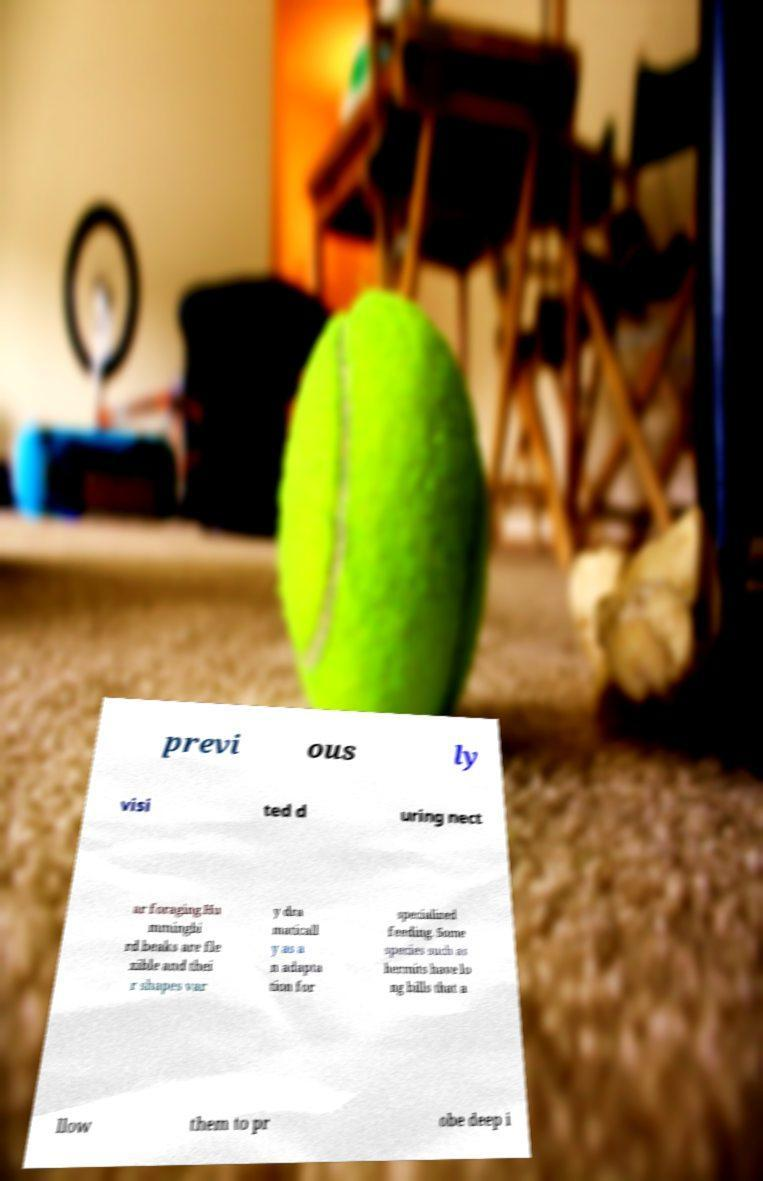I need the written content from this picture converted into text. Can you do that? previ ous ly visi ted d uring nect ar foraging.Hu mmingbi rd beaks are fle xible and thei r shapes var y dra maticall y as a n adapta tion for specialized feeding. Some species such as hermits have lo ng bills that a llow them to pr obe deep i 